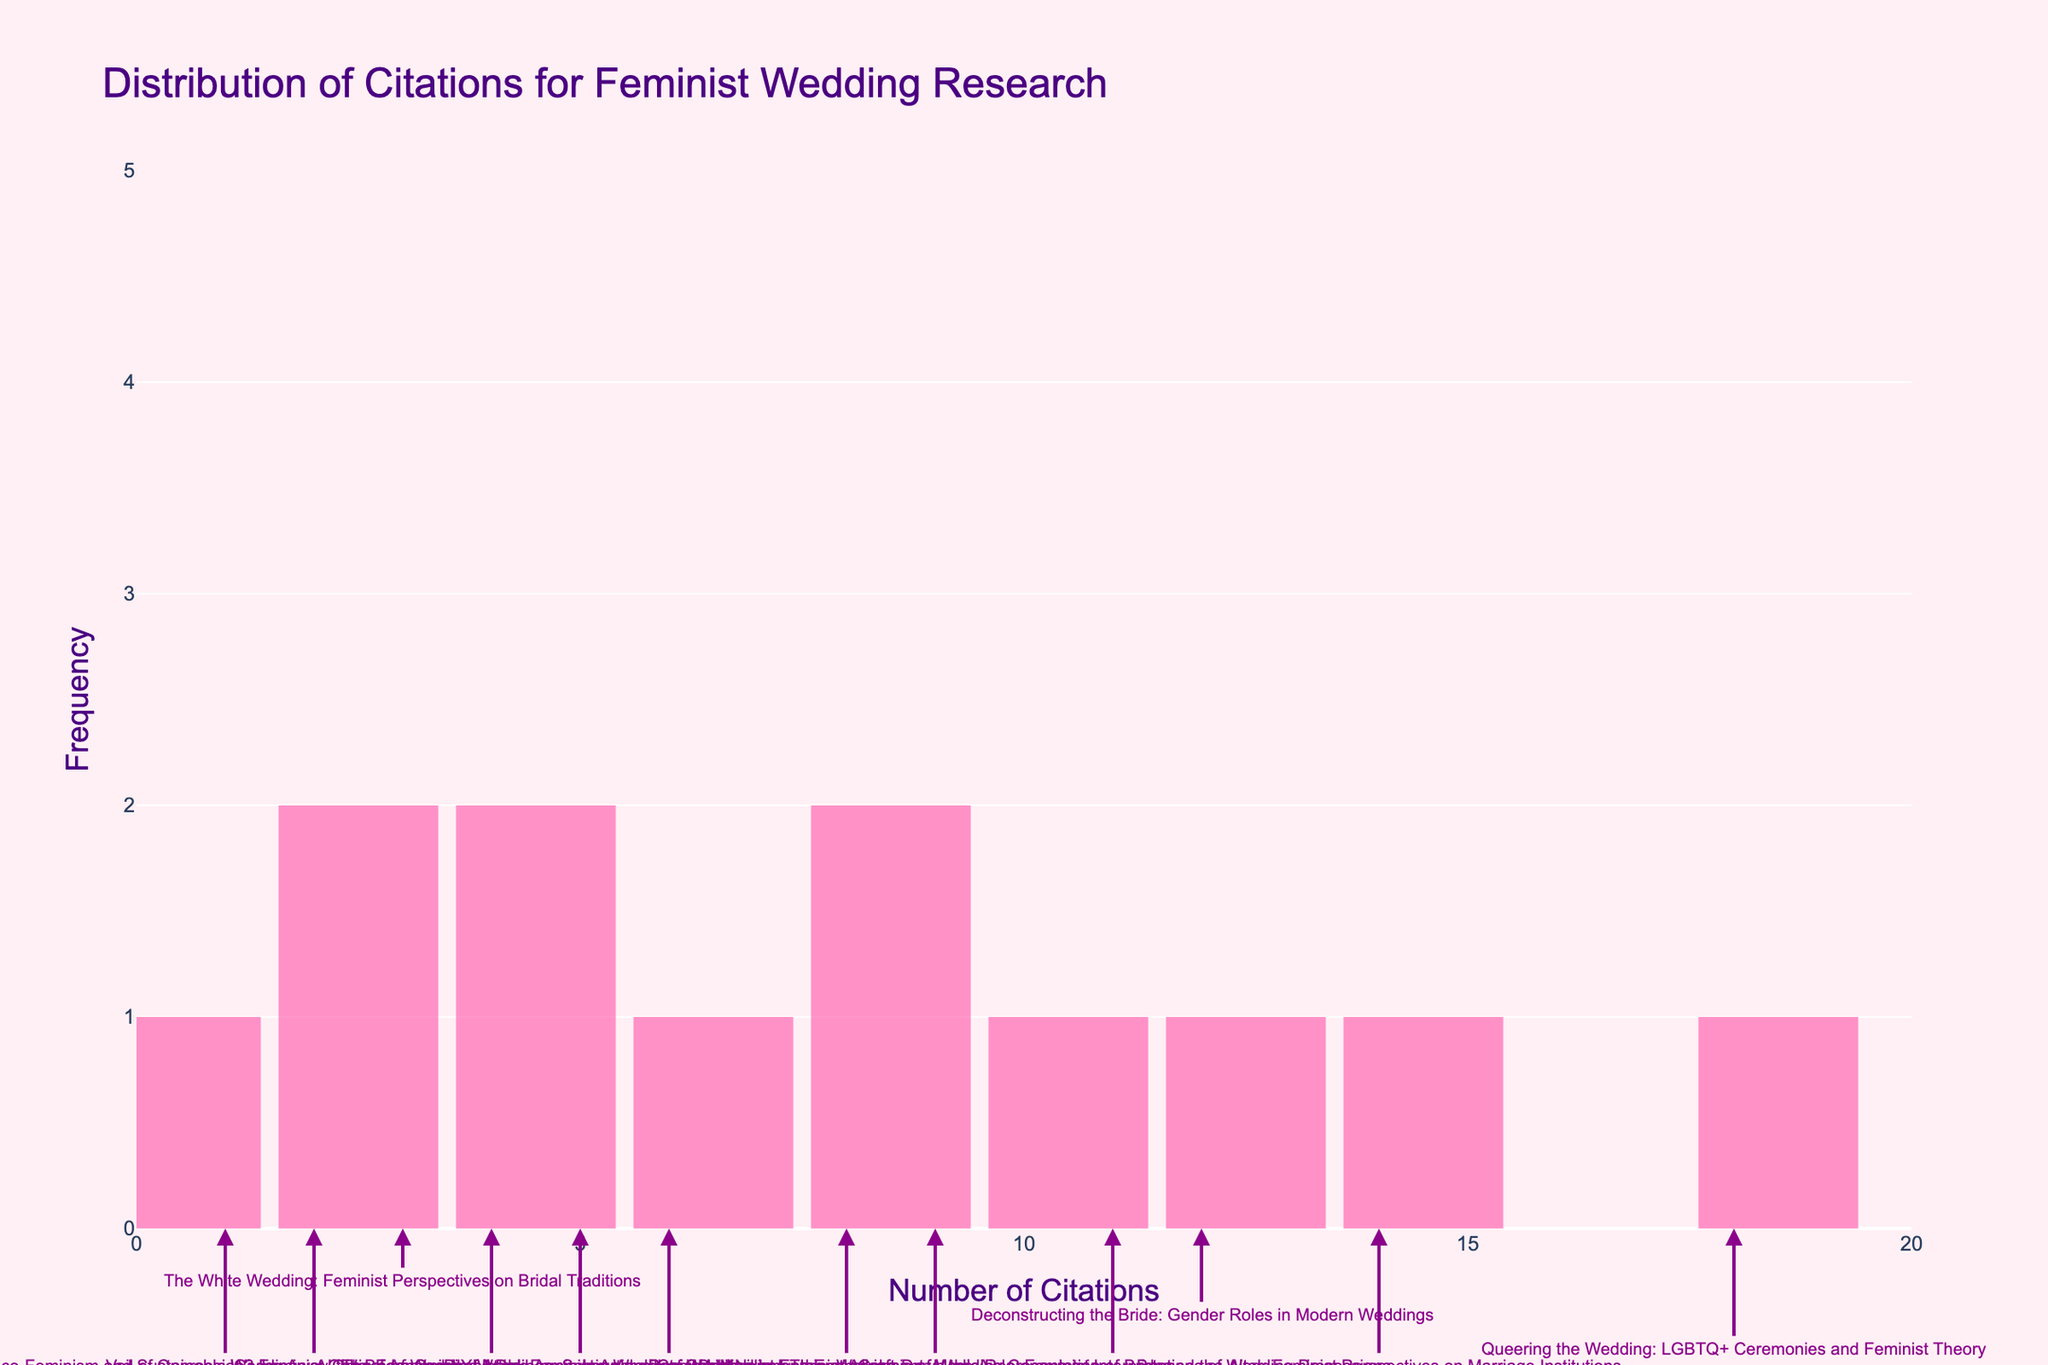What is the title of the figure? The title of the figure is given at the top of the plot. It is "Distribution of Citations for Feminist Wedding Research."
Answer: Distribution of Citations for Feminist Wedding Research What does the x-axis represent? The x-axis title is "Number of Citations," which indicates it represents the citation count of each paper.
Answer: Number of Citations What color are the histogram bars? The histogram bars are light pink. This can be observed from the color of the bars in the plot.
Answer: Light pink How many papers have 5 citations? There is one bar with a height equivalent to the frequency corresponding to 5 citations. You can directly see there is 1 paper with 5 citations.
Answer: 1 Which paper has the highest number of citations? The annotation on the highest bar indicates the paper with 18 citations, which is titled "Queering the Wedding: LGBTQ+ Ceremonies and Feminist Theory."
Answer: Queering the Wedding: LGBTQ+ Ceremonies and Feminist Theory What is the range of citation counts shown on the x-axis? The x-axis starts at 0 and goes up to 20, as indicated by the tick marks.
Answer: 0 to 20 How many papers have citation counts of fewer than 5? By looking at the bars corresponding to citation counts of 1, 2, 3, and 4, and adding their frequencies, you get 1+1+1+1=4.
Answer: 4 What is the average number of citations for all papers? Sum all citation counts: 3+12+18+5+9+2+14+6+11+4+8+1=93. Divide by the number of papers, which is 12. So, 93/12 = 7.75.
Answer: 7.75 Which two papers have similar citation counts and what are they? The papers with 12 and 14 citations are closest in count. They are "Deconstructing the Bride: Gender Roles in Modern Weddings" and "Beyond the Altar: Feminist Perspectives on Marriage Institutions," respectively.
Answer: Deconstructing the Bride: Gender Roles in Modern Weddings, Beyond the Altar: Feminist Perspectives on Marriage Institutions Between citations of 8 and 12, which has more research papers? The annotation and bar height for citation count 12 shows 2 papers, while the bar for citation count 8 shows 1 paper.
Answer: 12 